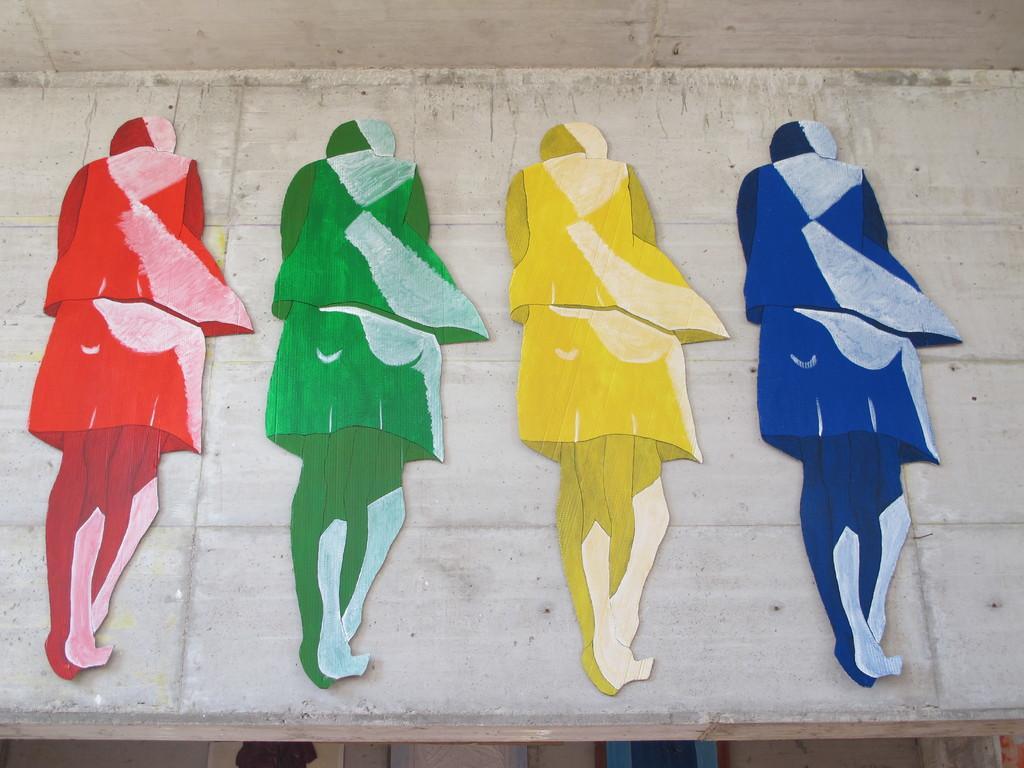Can you describe this image briefly? In the center of the image there is a wall and roof. On the wall, we can see some different color paintings, which looks like human painting. At the bottom of the image, we can see posters and a few other objects. 